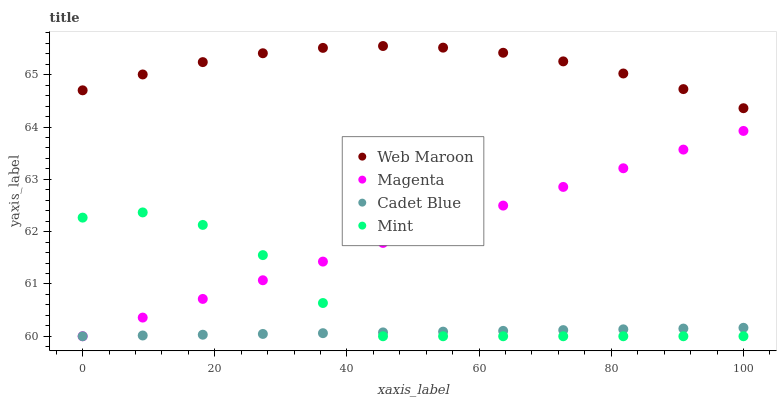Does Cadet Blue have the minimum area under the curve?
Answer yes or no. Yes. Does Web Maroon have the maximum area under the curve?
Answer yes or no. Yes. Does Magenta have the minimum area under the curve?
Answer yes or no. No. Does Magenta have the maximum area under the curve?
Answer yes or no. No. Is Cadet Blue the smoothest?
Answer yes or no. Yes. Is Mint the roughest?
Answer yes or no. Yes. Is Magenta the smoothest?
Answer yes or no. No. Is Magenta the roughest?
Answer yes or no. No. Does Mint have the lowest value?
Answer yes or no. Yes. Does Web Maroon have the lowest value?
Answer yes or no. No. Does Web Maroon have the highest value?
Answer yes or no. Yes. Does Magenta have the highest value?
Answer yes or no. No. Is Cadet Blue less than Web Maroon?
Answer yes or no. Yes. Is Web Maroon greater than Cadet Blue?
Answer yes or no. Yes. Does Magenta intersect Cadet Blue?
Answer yes or no. Yes. Is Magenta less than Cadet Blue?
Answer yes or no. No. Is Magenta greater than Cadet Blue?
Answer yes or no. No. Does Cadet Blue intersect Web Maroon?
Answer yes or no. No. 